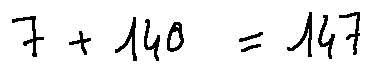<formula> <loc_0><loc_0><loc_500><loc_500>7 + 1 4 0 = 1 4 7</formula> 